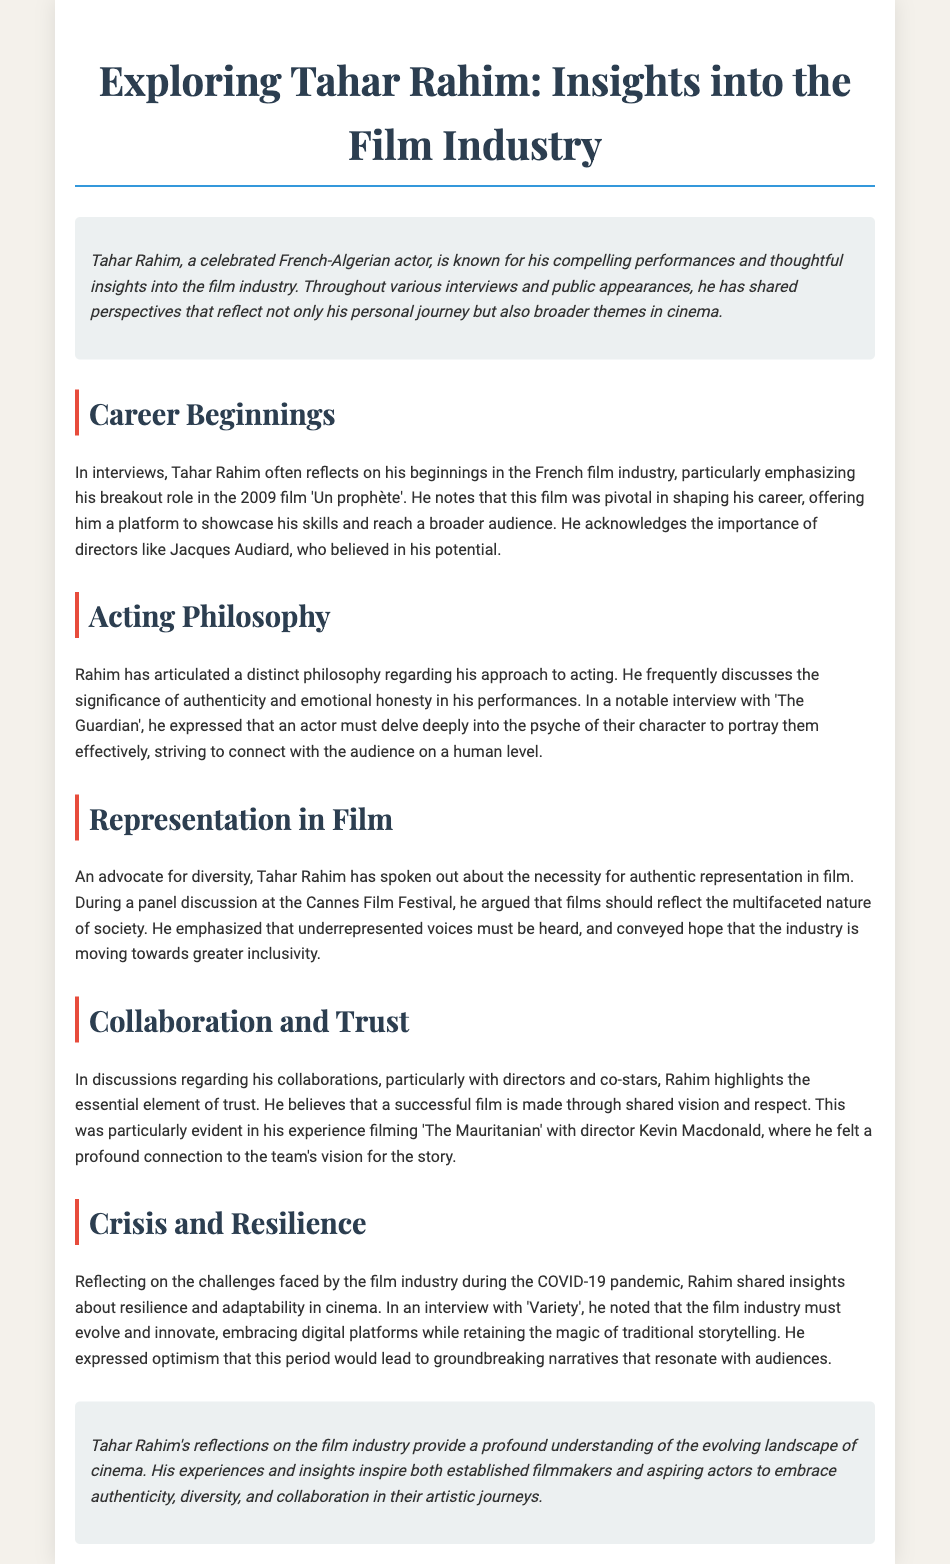What was Tahar Rahim's breakout role? The document states that his breakout role was in the 2009 film 'Un prophète'.
Answer: 'Un prophète' Who directed 'Un prophète'? The document mentions that Jacques Audiard directed 'Un prophète'.
Answer: Jacques Audiard What does Tahar Rahim emphasize as significant in acting? The document notes that he discusses the significance of authenticity and emotional honesty in performances.
Answer: Authenticity and emotional honesty Where did Rahim express his views on representation in film? According to the document, he spoke about representation during a panel discussion at the Cannes Film Festival.
Answer: Cannes Film Festival What does Rahim believe is essential for successful film collaboration? The document states that he highlights the essential element of trust in collaboration.
Answer: Trust How does Rahim describe the film industry's need during the COVID-19 pandemic? He notes that the film industry must evolve and innovate during the pandemic.
Answer: Evolve and innovate What is a recurring theme in Tahar Rahim's reflections? The document indicates that authenticity, diversity, and collaboration are recurring themes in his reflections.
Answer: Authenticity, diversity, and collaboration What platform did Rahim discuss for future storytelling? He expressed the need to embrace digital platforms while retaining traditional storytelling.
Answer: Digital platforms Which film did Rahim collaborate on with Kevin Macdonald? The document mentions that he had a significant collaboration on 'The Mauritanian'.
Answer: 'The Mauritanian' 